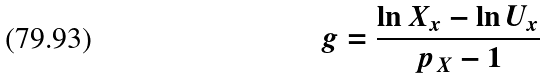Convert formula to latex. <formula><loc_0><loc_0><loc_500><loc_500>g = \frac { \ln X _ { x } - \ln U _ { x } } { p _ { X } - 1 }</formula> 